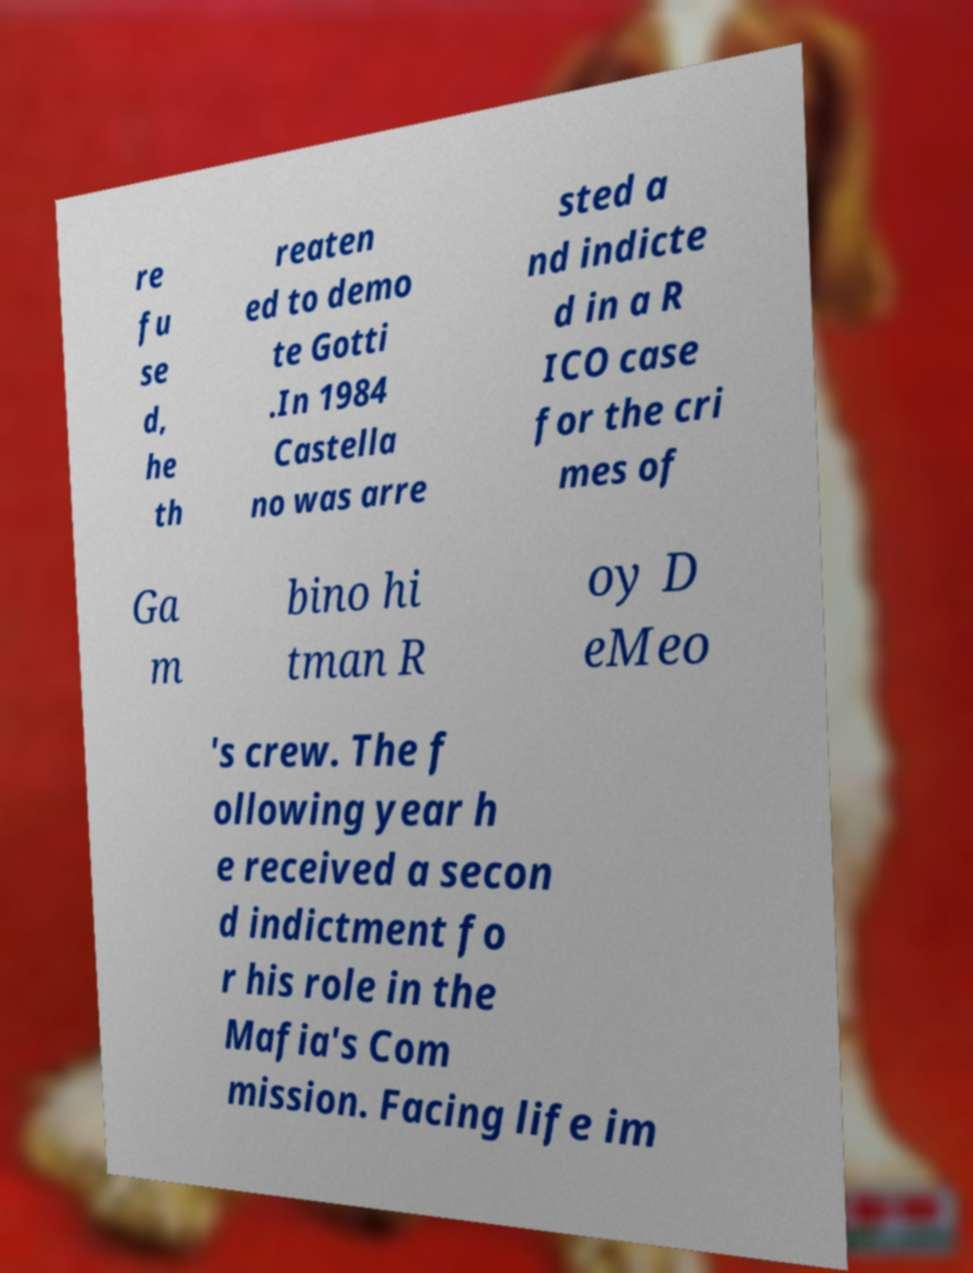Can you read and provide the text displayed in the image?This photo seems to have some interesting text. Can you extract and type it out for me? re fu se d, he th reaten ed to demo te Gotti .In 1984 Castella no was arre sted a nd indicte d in a R ICO case for the cri mes of Ga m bino hi tman R oy D eMeo 's crew. The f ollowing year h e received a secon d indictment fo r his role in the Mafia's Com mission. Facing life im 